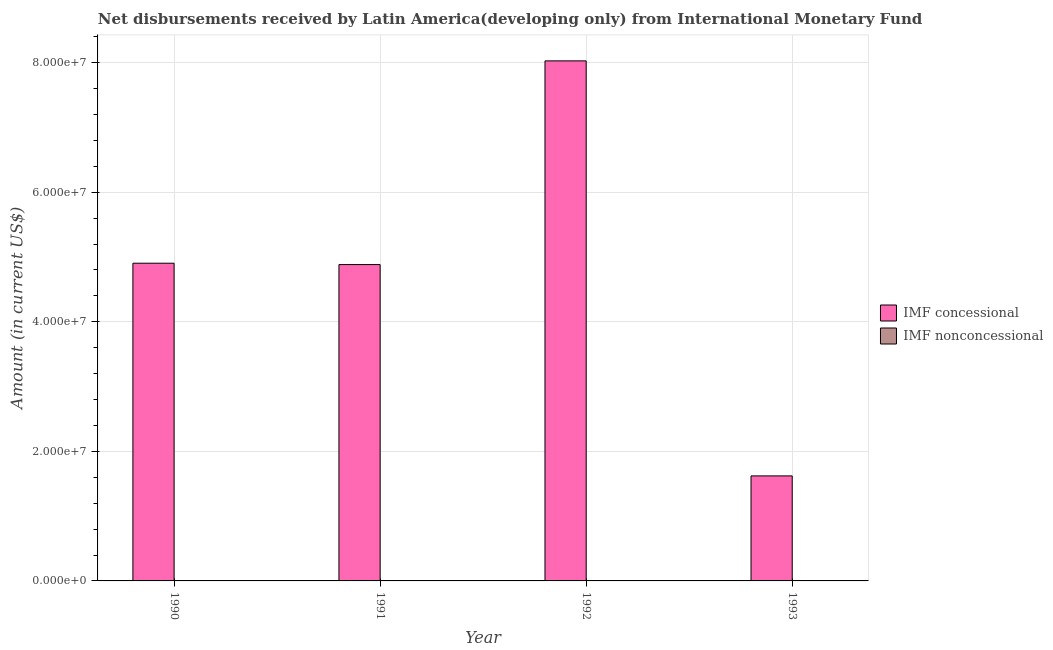Are the number of bars on each tick of the X-axis equal?
Give a very brief answer. Yes. How many bars are there on the 3rd tick from the left?
Ensure brevity in your answer.  1. Across all years, what is the maximum net concessional disbursements from imf?
Your answer should be compact. 8.03e+07. What is the difference between the net concessional disbursements from imf in 1990 and that in 1992?
Give a very brief answer. -3.12e+07. What is the difference between the net concessional disbursements from imf in 1991 and the net non concessional disbursements from imf in 1992?
Offer a very short reply. -3.14e+07. What is the average net concessional disbursements from imf per year?
Offer a terse response. 4.86e+07. In the year 1993, what is the difference between the net concessional disbursements from imf and net non concessional disbursements from imf?
Ensure brevity in your answer.  0. In how many years, is the net concessional disbursements from imf greater than 44000000 US$?
Offer a very short reply. 3. What is the ratio of the net concessional disbursements from imf in 1990 to that in 1991?
Your answer should be compact. 1. Is the net concessional disbursements from imf in 1990 less than that in 1992?
Your answer should be compact. Yes. Is the difference between the net concessional disbursements from imf in 1992 and 1993 greater than the difference between the net non concessional disbursements from imf in 1992 and 1993?
Provide a succinct answer. No. What is the difference between the highest and the second highest net concessional disbursements from imf?
Your answer should be very brief. 3.12e+07. What is the difference between the highest and the lowest net concessional disbursements from imf?
Your answer should be compact. 6.41e+07. In how many years, is the net concessional disbursements from imf greater than the average net concessional disbursements from imf taken over all years?
Offer a terse response. 3. Are all the bars in the graph horizontal?
Keep it short and to the point. No. How many years are there in the graph?
Your response must be concise. 4. What is the difference between two consecutive major ticks on the Y-axis?
Ensure brevity in your answer.  2.00e+07. Are the values on the major ticks of Y-axis written in scientific E-notation?
Provide a short and direct response. Yes. Does the graph contain any zero values?
Offer a very short reply. Yes. Does the graph contain grids?
Give a very brief answer. Yes. How many legend labels are there?
Your response must be concise. 2. How are the legend labels stacked?
Offer a very short reply. Vertical. What is the title of the graph?
Your answer should be compact. Net disbursements received by Latin America(developing only) from International Monetary Fund. What is the label or title of the Y-axis?
Ensure brevity in your answer.  Amount (in current US$). What is the Amount (in current US$) in IMF concessional in 1990?
Ensure brevity in your answer.  4.90e+07. What is the Amount (in current US$) in IMF nonconcessional in 1990?
Offer a very short reply. 0. What is the Amount (in current US$) of IMF concessional in 1991?
Give a very brief answer. 4.88e+07. What is the Amount (in current US$) of IMF nonconcessional in 1991?
Your answer should be very brief. 0. What is the Amount (in current US$) of IMF concessional in 1992?
Your answer should be very brief. 8.03e+07. What is the Amount (in current US$) of IMF nonconcessional in 1992?
Ensure brevity in your answer.  0. What is the Amount (in current US$) of IMF concessional in 1993?
Provide a succinct answer. 1.62e+07. Across all years, what is the maximum Amount (in current US$) of IMF concessional?
Offer a very short reply. 8.03e+07. Across all years, what is the minimum Amount (in current US$) of IMF concessional?
Your answer should be compact. 1.62e+07. What is the total Amount (in current US$) of IMF concessional in the graph?
Your answer should be very brief. 1.94e+08. What is the total Amount (in current US$) in IMF nonconcessional in the graph?
Your response must be concise. 0. What is the difference between the Amount (in current US$) of IMF concessional in 1990 and that in 1991?
Offer a very short reply. 2.09e+05. What is the difference between the Amount (in current US$) of IMF concessional in 1990 and that in 1992?
Ensure brevity in your answer.  -3.12e+07. What is the difference between the Amount (in current US$) in IMF concessional in 1990 and that in 1993?
Keep it short and to the point. 3.28e+07. What is the difference between the Amount (in current US$) of IMF concessional in 1991 and that in 1992?
Make the answer very short. -3.14e+07. What is the difference between the Amount (in current US$) in IMF concessional in 1991 and that in 1993?
Your answer should be compact. 3.26e+07. What is the difference between the Amount (in current US$) in IMF concessional in 1992 and that in 1993?
Keep it short and to the point. 6.41e+07. What is the average Amount (in current US$) of IMF concessional per year?
Make the answer very short. 4.86e+07. What is the average Amount (in current US$) in IMF nonconcessional per year?
Your answer should be very brief. 0. What is the ratio of the Amount (in current US$) of IMF concessional in 1990 to that in 1992?
Make the answer very short. 0.61. What is the ratio of the Amount (in current US$) in IMF concessional in 1990 to that in 1993?
Your answer should be compact. 3.03. What is the ratio of the Amount (in current US$) in IMF concessional in 1991 to that in 1992?
Provide a succinct answer. 0.61. What is the ratio of the Amount (in current US$) of IMF concessional in 1991 to that in 1993?
Make the answer very short. 3.01. What is the ratio of the Amount (in current US$) in IMF concessional in 1992 to that in 1993?
Make the answer very short. 4.95. What is the difference between the highest and the second highest Amount (in current US$) in IMF concessional?
Offer a terse response. 3.12e+07. What is the difference between the highest and the lowest Amount (in current US$) of IMF concessional?
Provide a short and direct response. 6.41e+07. 